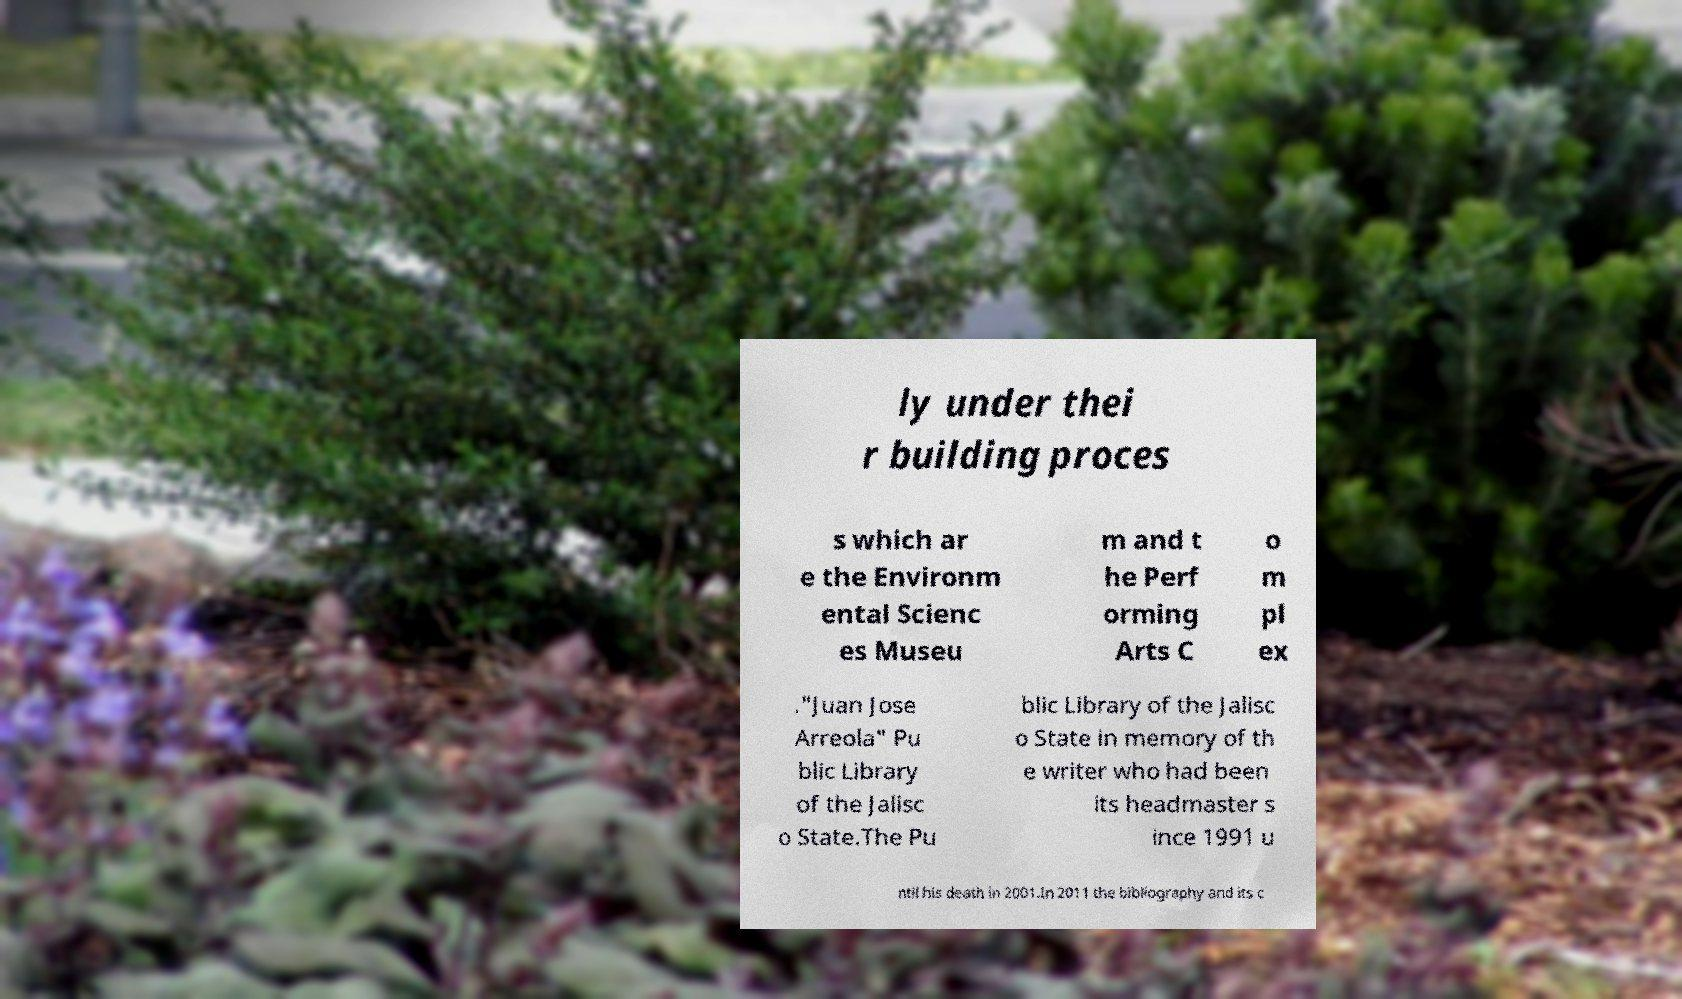Can you read and provide the text displayed in the image?This photo seems to have some interesting text. Can you extract and type it out for me? ly under thei r building proces s which ar e the Environm ental Scienc es Museu m and t he Perf orming Arts C o m pl ex ."Juan Jose Arreola" Pu blic Library of the Jalisc o State.The Pu blic Library of the Jalisc o State in memory of th e writer who had been its headmaster s ince 1991 u ntil his death in 2001.In 2011 the bibliography and its c 